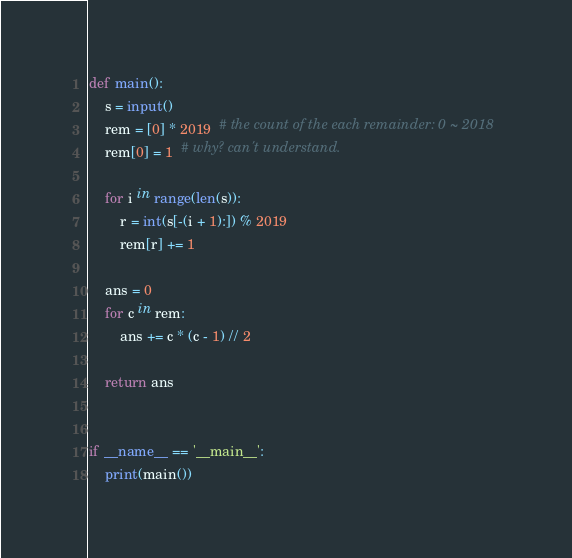<code> <loc_0><loc_0><loc_500><loc_500><_Python_>def main():
    s = input()
    rem = [0] * 2019  # the count of the each remainder: 0 ~ 2018
    rem[0] = 1  # why? can't understand.

    for i in range(len(s)):
        r = int(s[-(i + 1):]) % 2019
        rem[r] += 1

    ans = 0
    for c in rem:
        ans += c * (c - 1) // 2

    return ans


if __name__ == '__main__':
    print(main())
</code> 